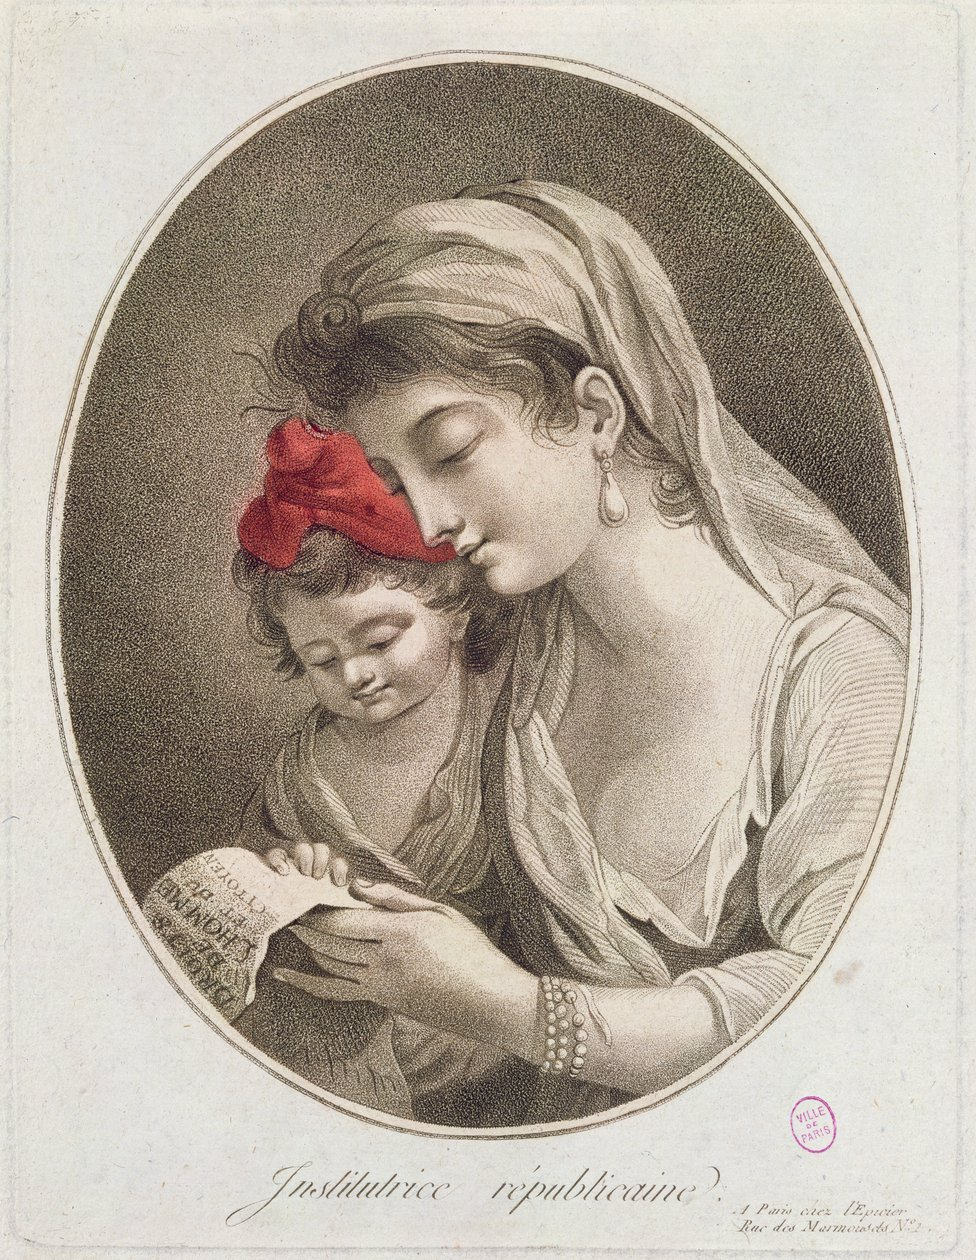Extraire la partie importante de ce contrat et l'enregistrer sous forme de tableau. Voici les principales informations du contrat extraites sous forme de tableau :

| Information | Détail |
|-------------|--------|
| Objet du contrat | Formation sur le e-market |
| Durée de la prestation | 5 jours, du 1er au 5 septembre |
| Lieu d'exécution | Dans les locaux du client à l'adresse mentionnée |
| Prix de la prestation | 5 000 euros HT, réglés dans les 8 jours de la réception de la facture |
| Obligations du prestataire | Exécuter la mission avec diligence et professionnalisme, respecter la confidentialité| Extraire toutes les parties de ce contrat et l'enregistrer sous forme de tableau. Voici le contrat extrait sous forme de tableau :

| Rubrique | Détail |
|----------|--------|
| Parties au contrat | - La société La Belle Affaire SARL, siège social 75 Boulevard Charles de Gaulle, 64700 Hendaye, RCS Bayonne 123 456 789, représentée par Aina Echegarray<br>- L'entreprise individuelle Francisco Herrera, 8 rue de la mer, 74300 Biarritz |
| Objet de la prestation | Formation sur le e-market |
| Durée et délai | - Durée de 5 jours<br>- Du 1er au 5 septembre |
| Lieu d'exécution | Dans les locaux du client à l'adresse mentionnée ci-dessus |
| Prix et modalités de paiement | - 5 000 euros HT<br>- Paiement dans les 8 jours de la réception de la facture |
| Obligations du prestataire | - Exécuter la mission avec diligence et professionnalisme<br>- Respecter l'obligation de confidentialité |

H: Merci, c'est très bien. Je peux maintenant poser des questions sur ce contrat ?

A: Oui, bien sûr, vous pouvez maintenant me poser vos questions sur ce contrat. Je serai heureux d'y répondre du mieux que je peux, en me basant sur les informations que j'ai extraites dans le tableau. Can you derive Equation 6 from the image? The image does not contain Equation 6. The image shows a mathematical derivation leading up to Equation 5, which expresses the reward function in terms of the optimal policy and reference policy under the Bradley-Terry model. It does not derive or present Equation 6 explicitly. The text mentions that the Bradley-Terry model depends only on the difference of rewards between two completions, but it does not derive the final expression shown in Equation 6. So I cannot directly derive Equation 6 from the information provided in this image alone. Décris l'image L'image montre une femme et un enfant dans une scène romantique. La femme, habillée de manière élégante avec des bijoux et un chapeau orné, a l'air de tenir doucement l'enfant endormi dans ses bras. Ils semblent être dans un intérieur, peut-être une chambre ou un salon, avec un arrière-plan sombre et flou. L'image a un style vintage ou classique, donnant une impression de tendresse et d'intimité entre la mère et l'enfant. 